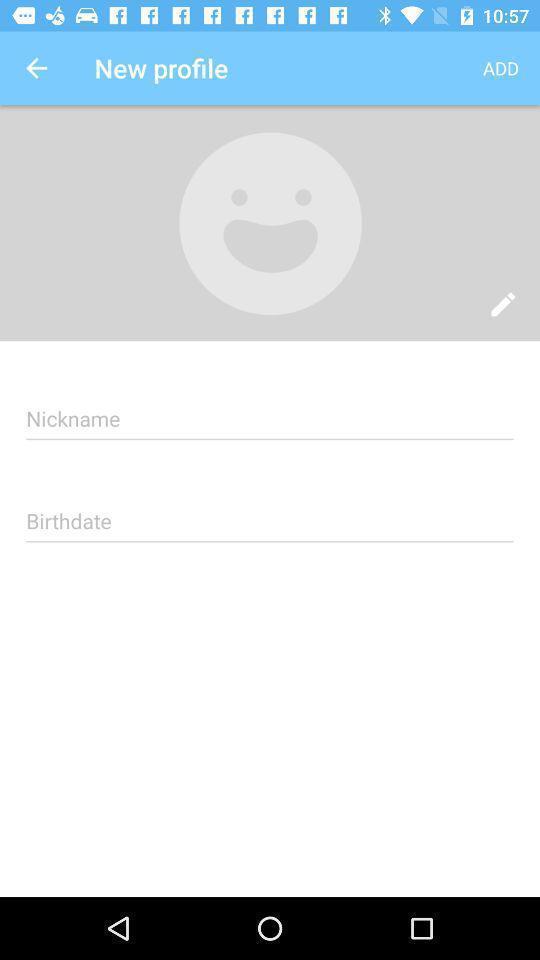Describe the visual elements of this screenshot. Social app for making new profile. 